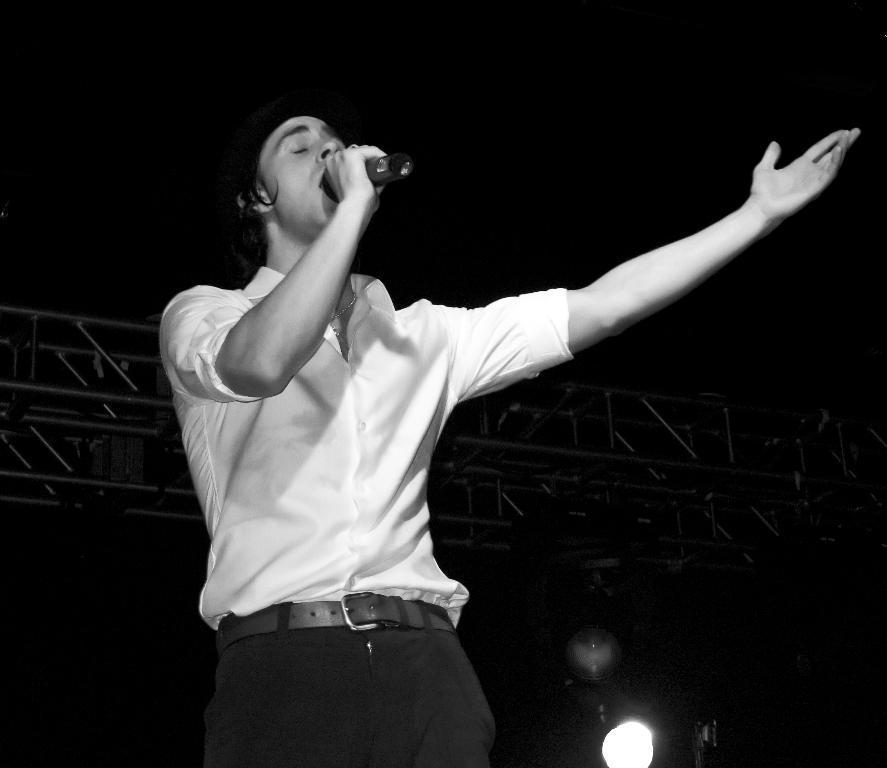Describe this image in one or two sentences. This is a black and white picture. Here we can see a man who is singing on the mike and this is light. 